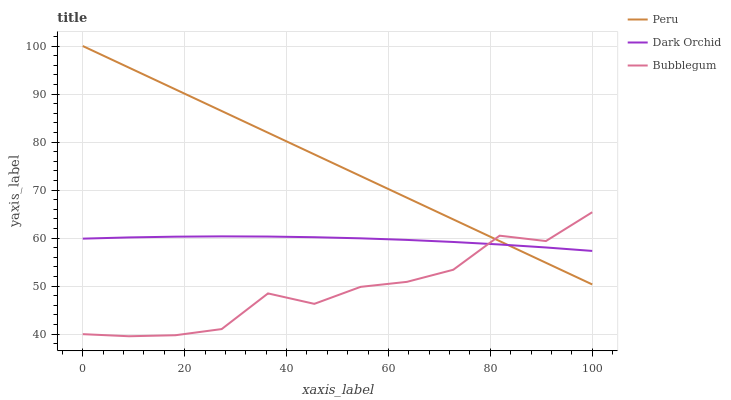Does Bubblegum have the minimum area under the curve?
Answer yes or no. Yes. Does Peru have the maximum area under the curve?
Answer yes or no. Yes. Does Dark Orchid have the minimum area under the curve?
Answer yes or no. No. Does Dark Orchid have the maximum area under the curve?
Answer yes or no. No. Is Peru the smoothest?
Answer yes or no. Yes. Is Bubblegum the roughest?
Answer yes or no. Yes. Is Dark Orchid the smoothest?
Answer yes or no. No. Is Dark Orchid the roughest?
Answer yes or no. No. Does Bubblegum have the lowest value?
Answer yes or no. Yes. Does Peru have the lowest value?
Answer yes or no. No. Does Peru have the highest value?
Answer yes or no. Yes. Does Dark Orchid have the highest value?
Answer yes or no. No. Does Bubblegum intersect Dark Orchid?
Answer yes or no. Yes. Is Bubblegum less than Dark Orchid?
Answer yes or no. No. Is Bubblegum greater than Dark Orchid?
Answer yes or no. No. 